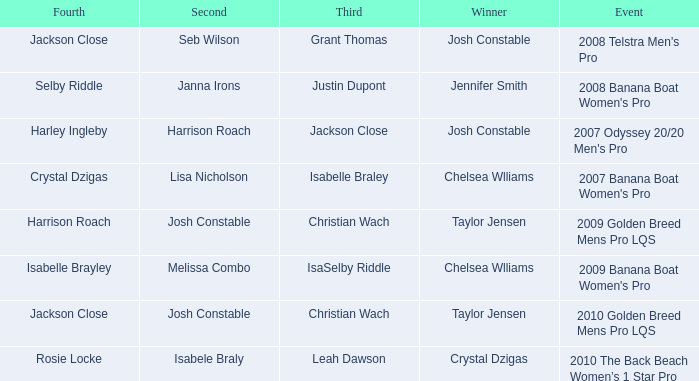Who was Fourth in the 2008 Telstra Men's Pro Event? Jackson Close. 